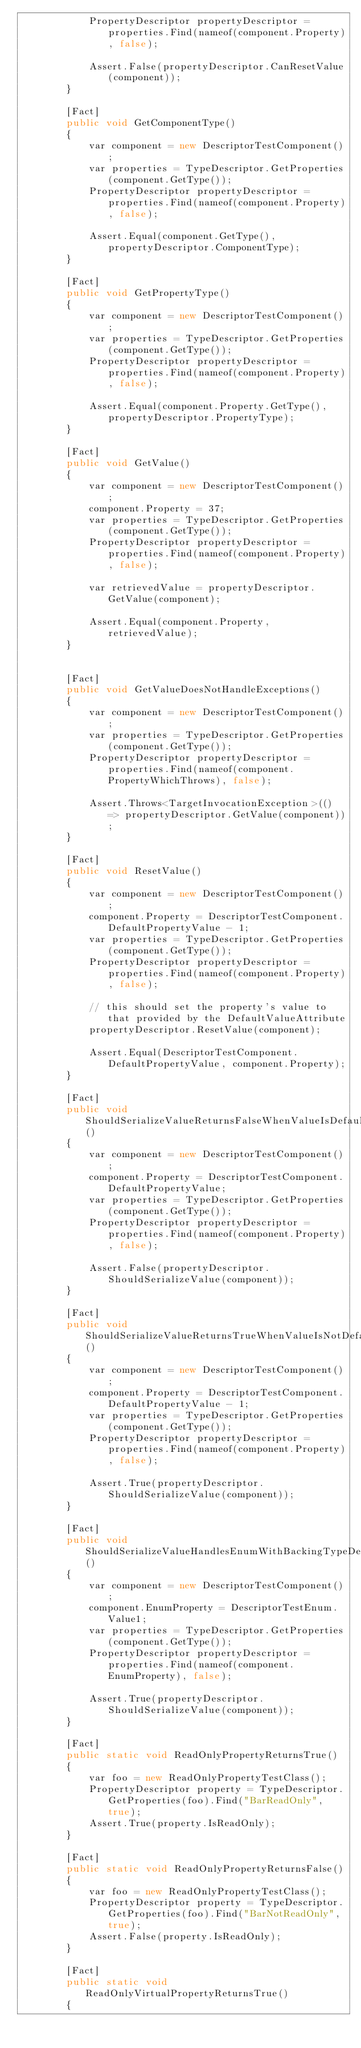<code> <loc_0><loc_0><loc_500><loc_500><_C#_>            PropertyDescriptor propertyDescriptor = properties.Find(nameof(component.Property), false);

            Assert.False(propertyDescriptor.CanResetValue(component));
        }

        [Fact]
        public void GetComponentType()
        {
            var component = new DescriptorTestComponent();
            var properties = TypeDescriptor.GetProperties(component.GetType());
            PropertyDescriptor propertyDescriptor = properties.Find(nameof(component.Property), false);

            Assert.Equal(component.GetType(), propertyDescriptor.ComponentType);
        }

        [Fact]
        public void GetPropertyType()
        {
            var component = new DescriptorTestComponent();
            var properties = TypeDescriptor.GetProperties(component.GetType());
            PropertyDescriptor propertyDescriptor = properties.Find(nameof(component.Property), false);

            Assert.Equal(component.Property.GetType(), propertyDescriptor.PropertyType);
        }

        [Fact]
        public void GetValue()
        {
            var component = new DescriptorTestComponent();
            component.Property = 37;
            var properties = TypeDescriptor.GetProperties(component.GetType());
            PropertyDescriptor propertyDescriptor = properties.Find(nameof(component.Property), false);

            var retrievedValue = propertyDescriptor.GetValue(component);

            Assert.Equal(component.Property, retrievedValue);
        }


        [Fact]
        public void GetValueDoesNotHandleExceptions()
        {
            var component = new DescriptorTestComponent();
            var properties = TypeDescriptor.GetProperties(component.GetType());
            PropertyDescriptor propertyDescriptor = properties.Find(nameof(component.PropertyWhichThrows), false);

            Assert.Throws<TargetInvocationException>(() => propertyDescriptor.GetValue(component));
        }

        [Fact]
        public void ResetValue()
        {
            var component = new DescriptorTestComponent();
            component.Property = DescriptorTestComponent.DefaultPropertyValue - 1;
            var properties = TypeDescriptor.GetProperties(component.GetType());
            PropertyDescriptor propertyDescriptor = properties.Find(nameof(component.Property), false);

            // this should set the property's value to that provided by the DefaultValueAttribute
            propertyDescriptor.ResetValue(component);

            Assert.Equal(DescriptorTestComponent.DefaultPropertyValue, component.Property);
        }

        [Fact]
        public void ShouldSerializeValueReturnsFalseWhenValueIsDefault()
        {
            var component = new DescriptorTestComponent();
            component.Property = DescriptorTestComponent.DefaultPropertyValue;
            var properties = TypeDescriptor.GetProperties(component.GetType());
            PropertyDescriptor propertyDescriptor = properties.Find(nameof(component.Property), false);

            Assert.False(propertyDescriptor.ShouldSerializeValue(component));
        }

        [Fact]
        public void ShouldSerializeValueReturnsTrueWhenValueIsNotDefault()
        {
            var component = new DescriptorTestComponent();
            component.Property = DescriptorTestComponent.DefaultPropertyValue - 1;
            var properties = TypeDescriptor.GetProperties(component.GetType());
            PropertyDescriptor propertyDescriptor = properties.Find(nameof(component.Property), false);

            Assert.True(propertyDescriptor.ShouldSerializeValue(component));
        }

        [Fact]
        public void ShouldSerializeValueHandlesEnumWithBackingTypeDefaultValue()
        {
            var component = new DescriptorTestComponent();
            component.EnumProperty = DescriptorTestEnum.Value1;
            var properties = TypeDescriptor.GetProperties(component.GetType());
            PropertyDescriptor propertyDescriptor = properties.Find(nameof(component.EnumProperty), false);

            Assert.True(propertyDescriptor.ShouldSerializeValue(component));
        }

        [Fact]
        public static void ReadOnlyPropertyReturnsTrue()
        {
            var foo = new ReadOnlyPropertyTestClass();
            PropertyDescriptor property = TypeDescriptor.GetProperties(foo).Find("BarReadOnly", true);
            Assert.True(property.IsReadOnly);
        }

        [Fact]
        public static void ReadOnlyPropertyReturnsFalse()
        {
            var foo = new ReadOnlyPropertyTestClass();
            PropertyDescriptor property = TypeDescriptor.GetProperties(foo).Find("BarNotReadOnly", true);
            Assert.False(property.IsReadOnly);
        }

        [Fact]
        public static void ReadOnlyVirtualPropertyReturnsTrue()
        {</code> 